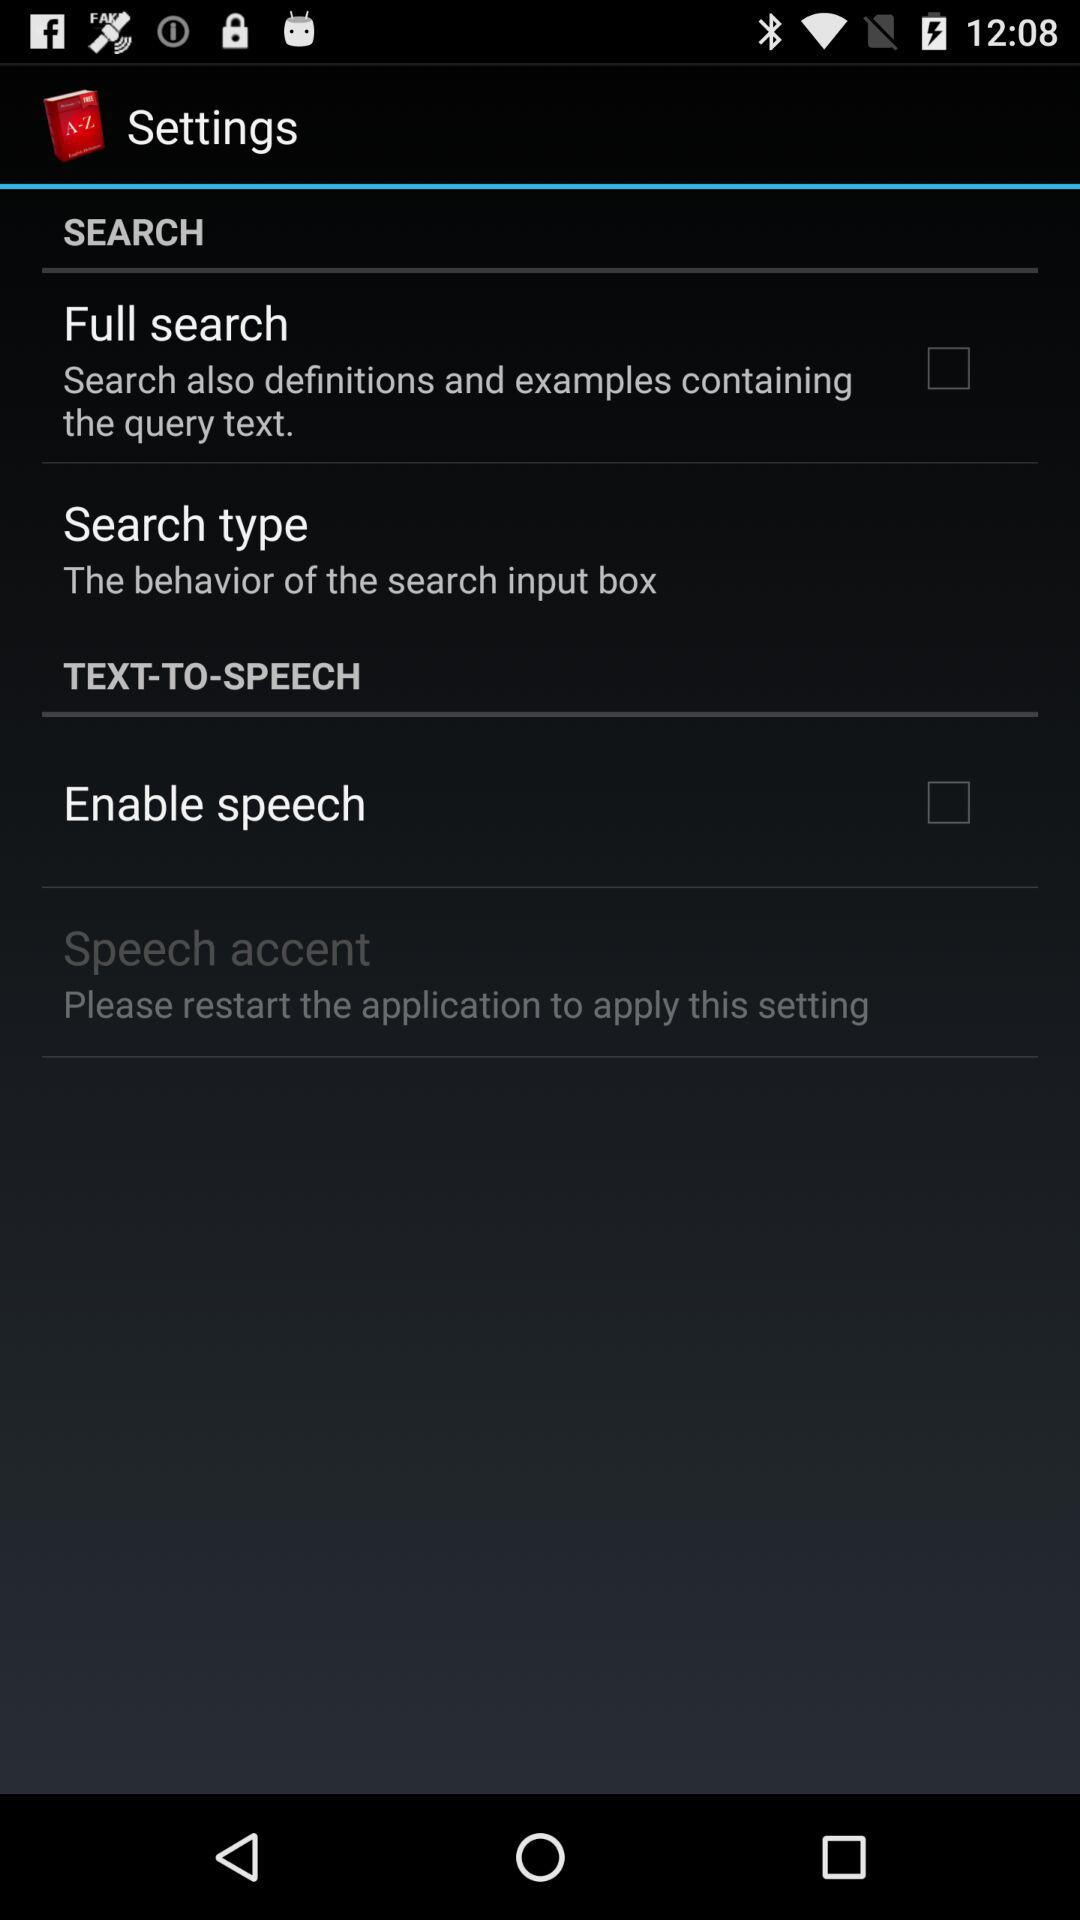What is the status of "Enable speech"? The status is off. 